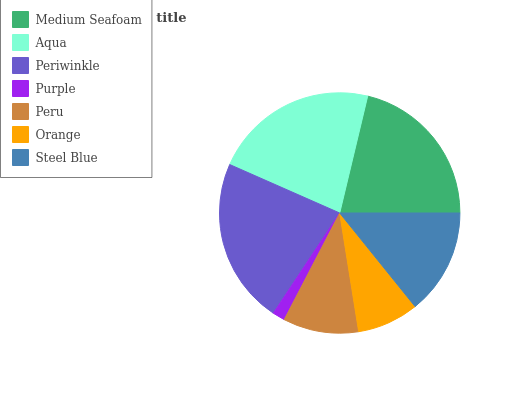Is Purple the minimum?
Answer yes or no. Yes. Is Periwinkle the maximum?
Answer yes or no. Yes. Is Aqua the minimum?
Answer yes or no. No. Is Aqua the maximum?
Answer yes or no. No. Is Aqua greater than Medium Seafoam?
Answer yes or no. Yes. Is Medium Seafoam less than Aqua?
Answer yes or no. Yes. Is Medium Seafoam greater than Aqua?
Answer yes or no. No. Is Aqua less than Medium Seafoam?
Answer yes or no. No. Is Steel Blue the high median?
Answer yes or no. Yes. Is Steel Blue the low median?
Answer yes or no. Yes. Is Aqua the high median?
Answer yes or no. No. Is Periwinkle the low median?
Answer yes or no. No. 